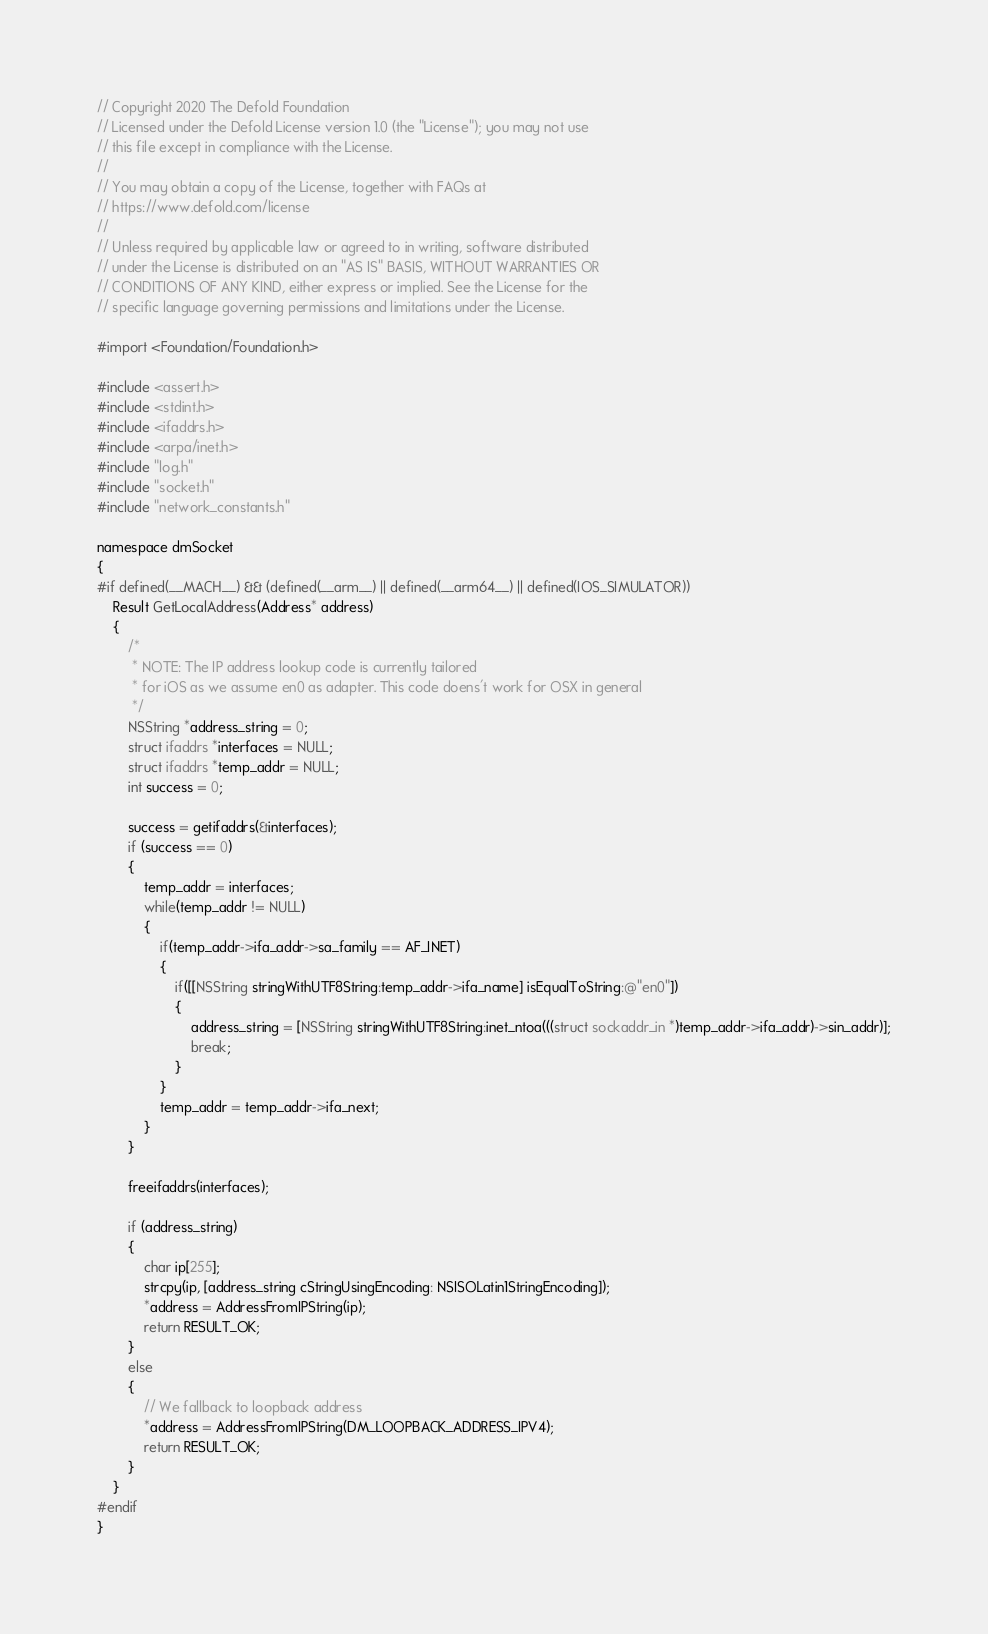Convert code to text. <code><loc_0><loc_0><loc_500><loc_500><_ObjectiveC_>// Copyright 2020 The Defold Foundation
// Licensed under the Defold License version 1.0 (the "License"); you may not use
// this file except in compliance with the License.
// 
// You may obtain a copy of the License, together with FAQs at
// https://www.defold.com/license
// 
// Unless required by applicable law or agreed to in writing, software distributed
// under the License is distributed on an "AS IS" BASIS, WITHOUT WARRANTIES OR
// CONDITIONS OF ANY KIND, either express or implied. See the License for the
// specific language governing permissions and limitations under the License.

#import <Foundation/Foundation.h>

#include <assert.h>
#include <stdint.h>
#include <ifaddrs.h>
#include <arpa/inet.h>
#include "log.h"
#include "socket.h"
#include "network_constants.h"

namespace dmSocket
{
#if defined(__MACH__) && (defined(__arm__) || defined(__arm64__) || defined(IOS_SIMULATOR))
    Result GetLocalAddress(Address* address)
    {
        /*
         * NOTE: The IP address lookup code is currently tailored
         * for iOS as we assume en0 as adapter. This code doens't work for OSX in general
         */
        NSString *address_string = 0;
        struct ifaddrs *interfaces = NULL;
        struct ifaddrs *temp_addr = NULL;
        int success = 0;

        success = getifaddrs(&interfaces);
        if (success == 0)
        {
            temp_addr = interfaces;
            while(temp_addr != NULL)
            {
                if(temp_addr->ifa_addr->sa_family == AF_INET)
                {
                    if([[NSString stringWithUTF8String:temp_addr->ifa_name] isEqualToString:@"en0"])
                    {
                        address_string = [NSString stringWithUTF8String:inet_ntoa(((struct sockaddr_in *)temp_addr->ifa_addr)->sin_addr)];
                        break;
                    }
                }
                temp_addr = temp_addr->ifa_next;
            }
        }

        freeifaddrs(interfaces);

        if (address_string)
        {
            char ip[255];
            strcpy(ip, [address_string cStringUsingEncoding: NSISOLatin1StringEncoding]);
            *address = AddressFromIPString(ip);
            return RESULT_OK;
        }
        else
        {
            // We fallback to loopback address
            *address = AddressFromIPString(DM_LOOPBACK_ADDRESS_IPV4);
            return RESULT_OK;
        }
    }
#endif
}

</code> 